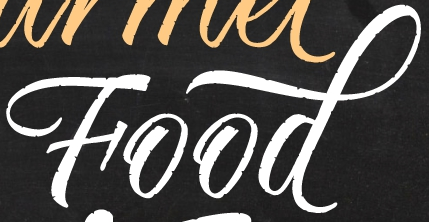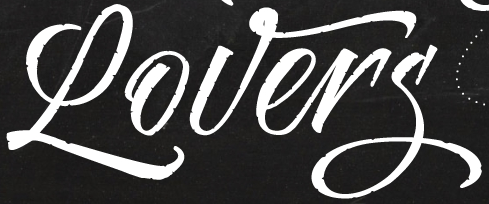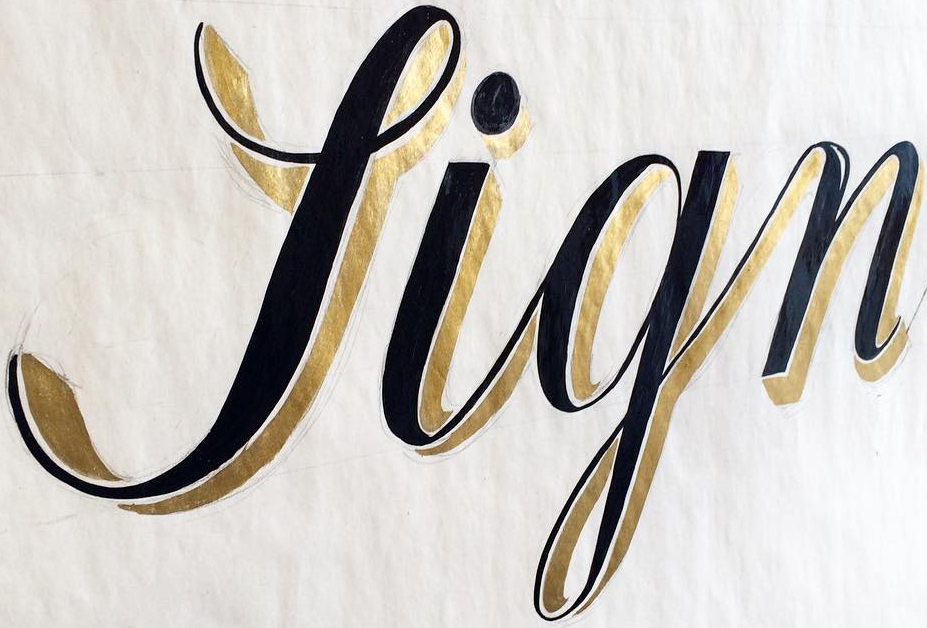What text is displayed in these images sequentially, separated by a semicolon? Food; Lovers; Sign 